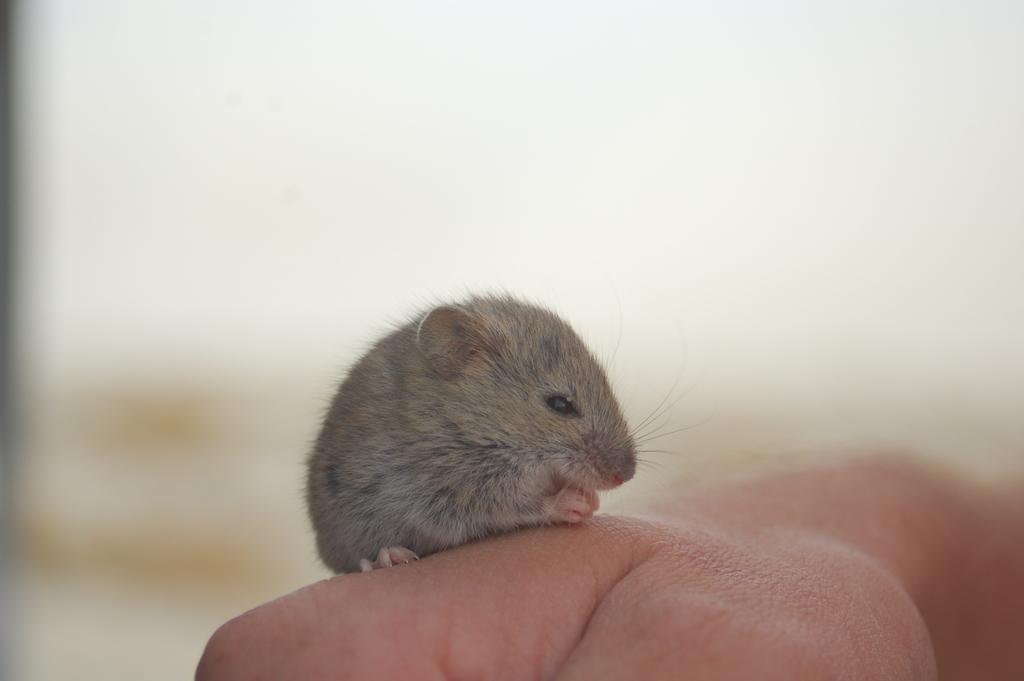What type of animal is in the image? There is a rat in the image. Where is the rat located in the image? The rat is on the hand of a person. What type of collar is the woman wearing in the image? There is no woman present in the image, only a rat on the hand of a person. 